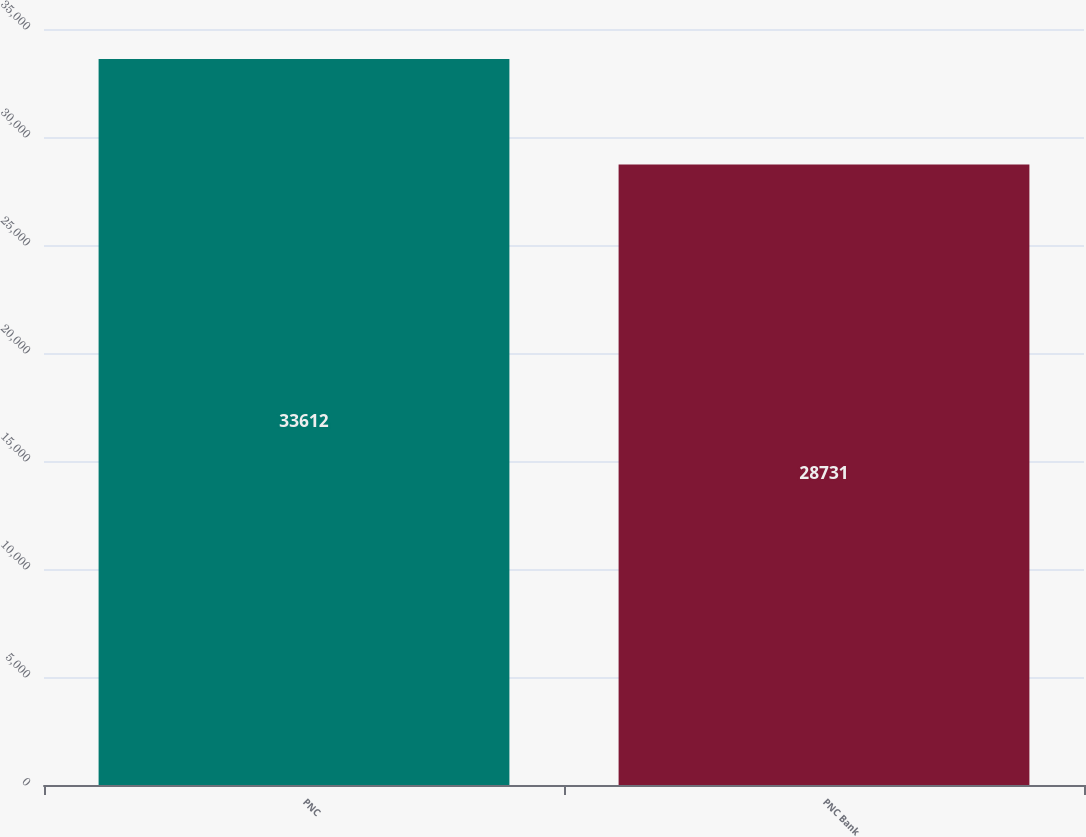Convert chart. <chart><loc_0><loc_0><loc_500><loc_500><bar_chart><fcel>PNC<fcel>PNC Bank<nl><fcel>33612<fcel>28731<nl></chart> 